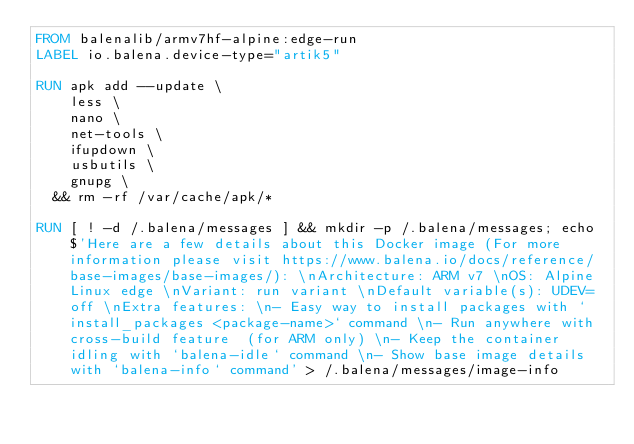<code> <loc_0><loc_0><loc_500><loc_500><_Dockerfile_>FROM balenalib/armv7hf-alpine:edge-run
LABEL io.balena.device-type="artik5"

RUN apk add --update \
		less \
		nano \
		net-tools \
		ifupdown \
		usbutils \
		gnupg \
	&& rm -rf /var/cache/apk/*

RUN [ ! -d /.balena/messages ] && mkdir -p /.balena/messages; echo $'Here are a few details about this Docker image (For more information please visit https://www.balena.io/docs/reference/base-images/base-images/): \nArchitecture: ARM v7 \nOS: Alpine Linux edge \nVariant: run variant \nDefault variable(s): UDEV=off \nExtra features: \n- Easy way to install packages with `install_packages <package-name>` command \n- Run anywhere with cross-build feature  (for ARM only) \n- Keep the container idling with `balena-idle` command \n- Show base image details with `balena-info` command' > /.balena/messages/image-info</code> 